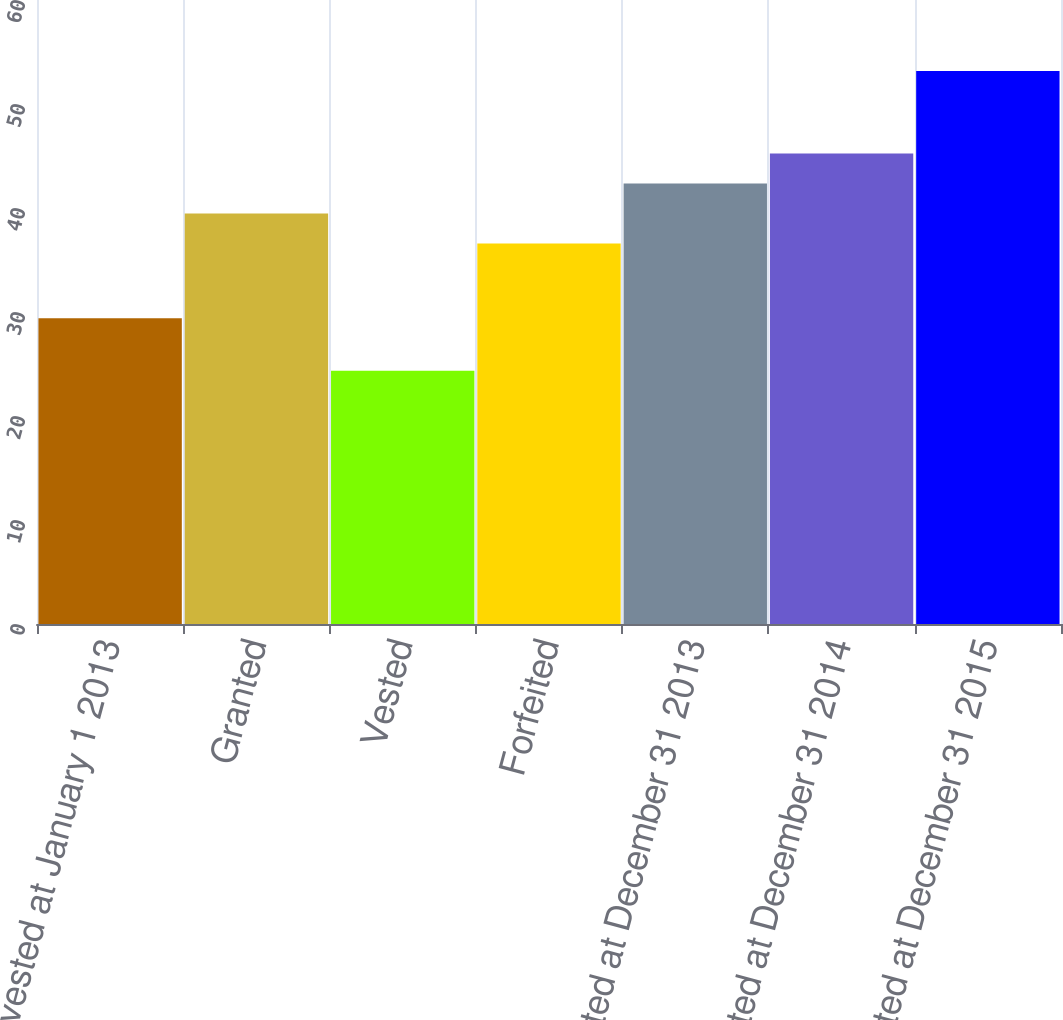Convert chart. <chart><loc_0><loc_0><loc_500><loc_500><bar_chart><fcel>Nonvested at January 1 2013<fcel>Granted<fcel>Vested<fcel>Forfeited<fcel>Nonvested at December 31 2013<fcel>Nonvested at December 31 2014<fcel>Nonvested at December 31 2015<nl><fcel>29.39<fcel>39.47<fcel>24.36<fcel>36.59<fcel>42.35<fcel>45.23<fcel>53.18<nl></chart> 